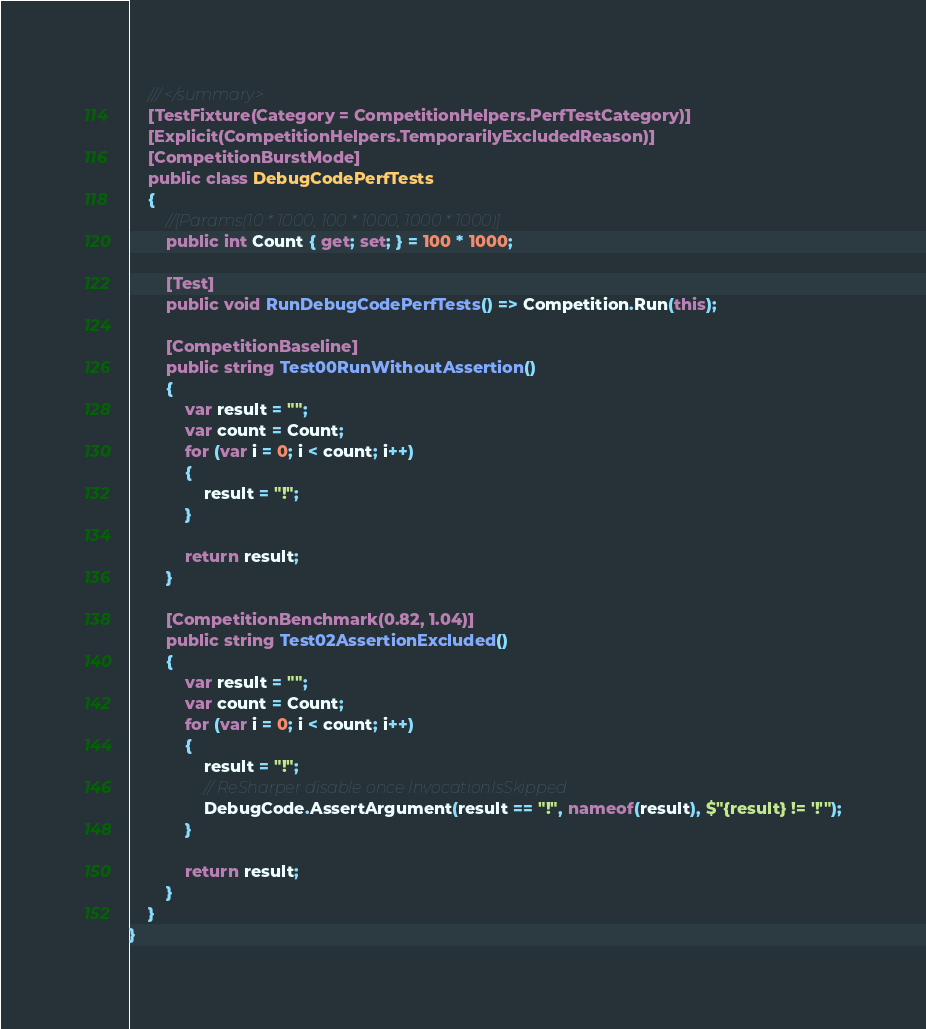<code> <loc_0><loc_0><loc_500><loc_500><_C#_>	/// </summary>
	[TestFixture(Category = CompetitionHelpers.PerfTestCategory)]
	[Explicit(CompetitionHelpers.TemporarilyExcludedReason)]
	[CompetitionBurstMode]
	public class DebugCodePerfTests
	{
		//[Params(10 * 1000, 100 * 1000, 1000 * 1000)]
		public int Count { get; set; } = 100 * 1000;

		[Test]
		public void RunDebugCodePerfTests() => Competition.Run(this);

		[CompetitionBaseline]
		public string Test00RunWithoutAssertion()
		{
			var result = "";
			var count = Count;
			for (var i = 0; i < count; i++)
			{
				result = "!";
			}

			return result;
		}

		[CompetitionBenchmark(0.82, 1.04)]
		public string Test02AssertionExcluded()
		{
			var result = "";
			var count = Count;
			for (var i = 0; i < count; i++)
			{
				result = "!";
				// ReSharper disable once InvocationIsSkipped
				DebugCode.AssertArgument(result == "!", nameof(result), $"{result} != '!'");
			}

			return result;
		}
	}
}</code> 